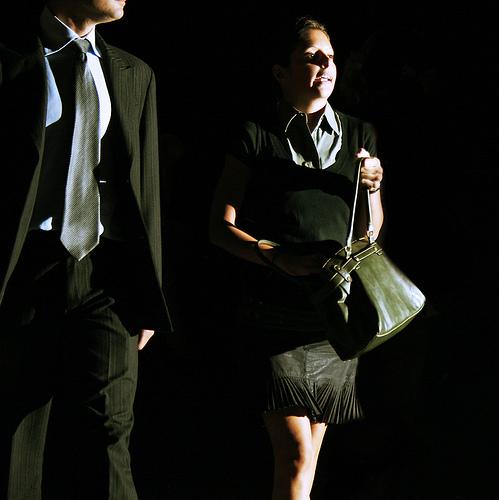What is the woman holding?
Short answer required. Purse. What is the woman wearing?
Be succinct. Dress. Is the man wearing a tie?
Be succinct. Yes. 